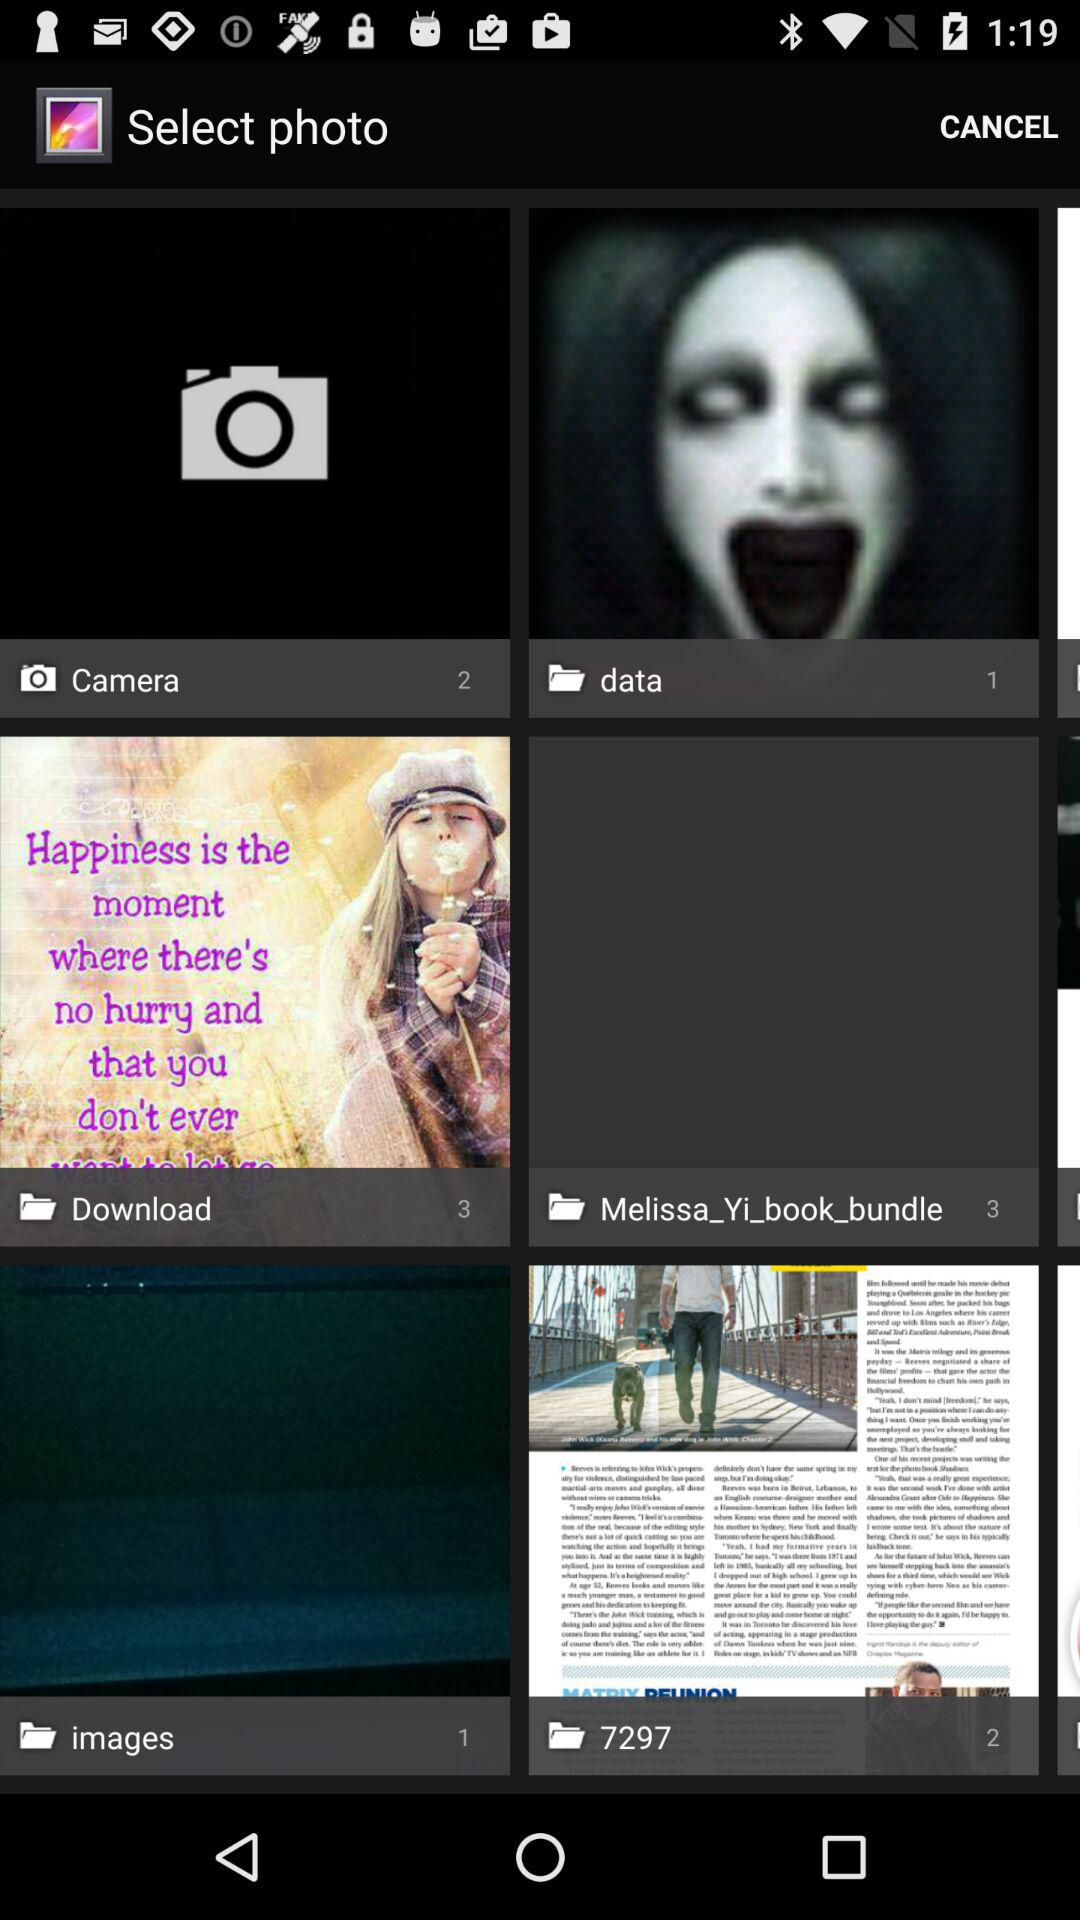How many images are in the "Download" folder? There are 3 images in the "Download" folder. 